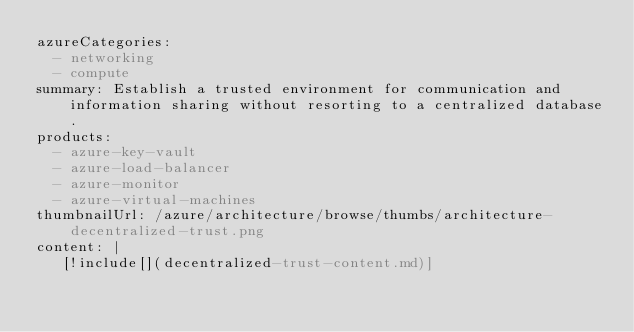Convert code to text. <code><loc_0><loc_0><loc_500><loc_500><_YAML_>azureCategories:
  - networking
  - compute
summary: Establish a trusted environment for communication and information sharing without resorting to a centralized database.
products:
  - azure-key-vault
  - azure-load-balancer
  - azure-monitor
  - azure-virtual-machines
thumbnailUrl: /azure/architecture/browse/thumbs/architecture-decentralized-trust.png
content: |
   [!include[](decentralized-trust-content.md)]
</code> 